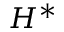Convert formula to latex. <formula><loc_0><loc_0><loc_500><loc_500>H ^ { * }</formula> 